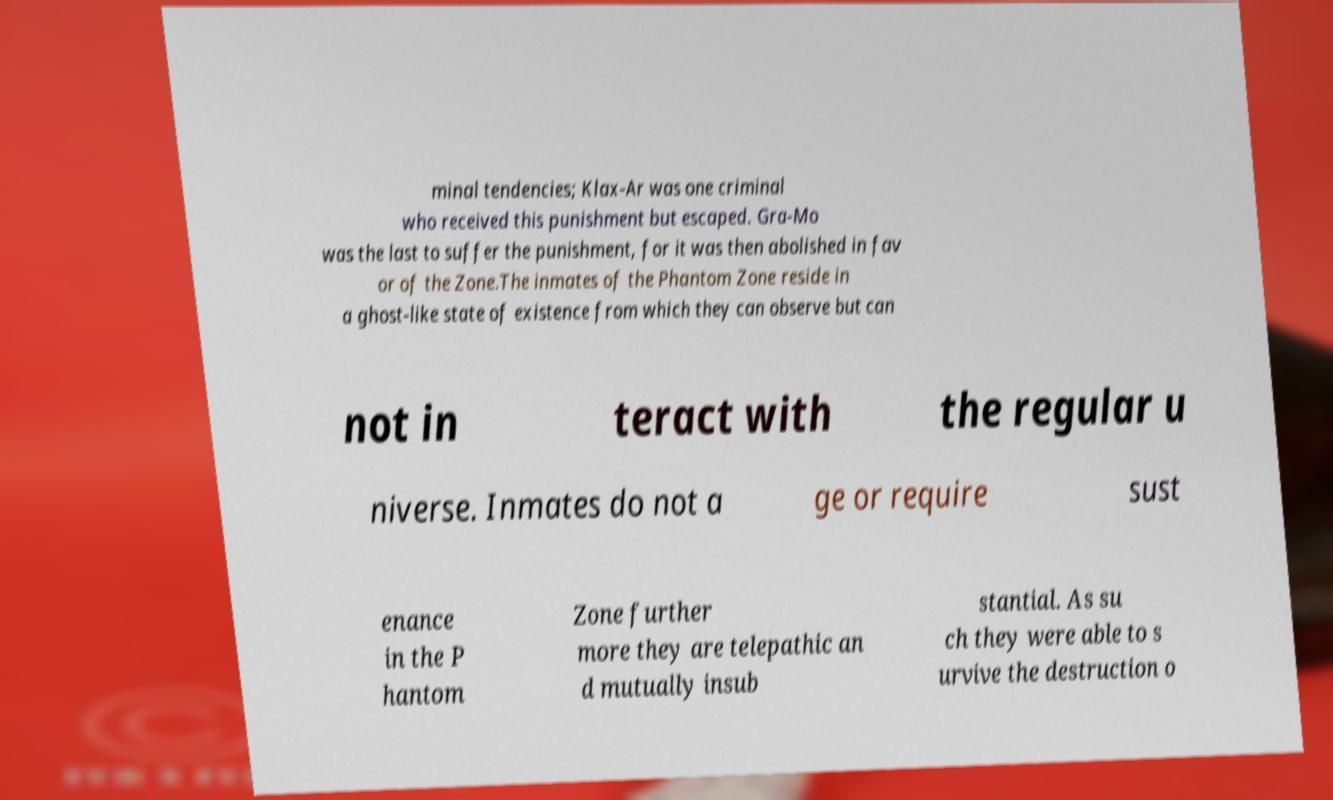What messages or text are displayed in this image? I need them in a readable, typed format. minal tendencies; Klax-Ar was one criminal who received this punishment but escaped. Gra-Mo was the last to suffer the punishment, for it was then abolished in fav or of the Zone.The inmates of the Phantom Zone reside in a ghost-like state of existence from which they can observe but can not in teract with the regular u niverse. Inmates do not a ge or require sust enance in the P hantom Zone further more they are telepathic an d mutually insub stantial. As su ch they were able to s urvive the destruction o 